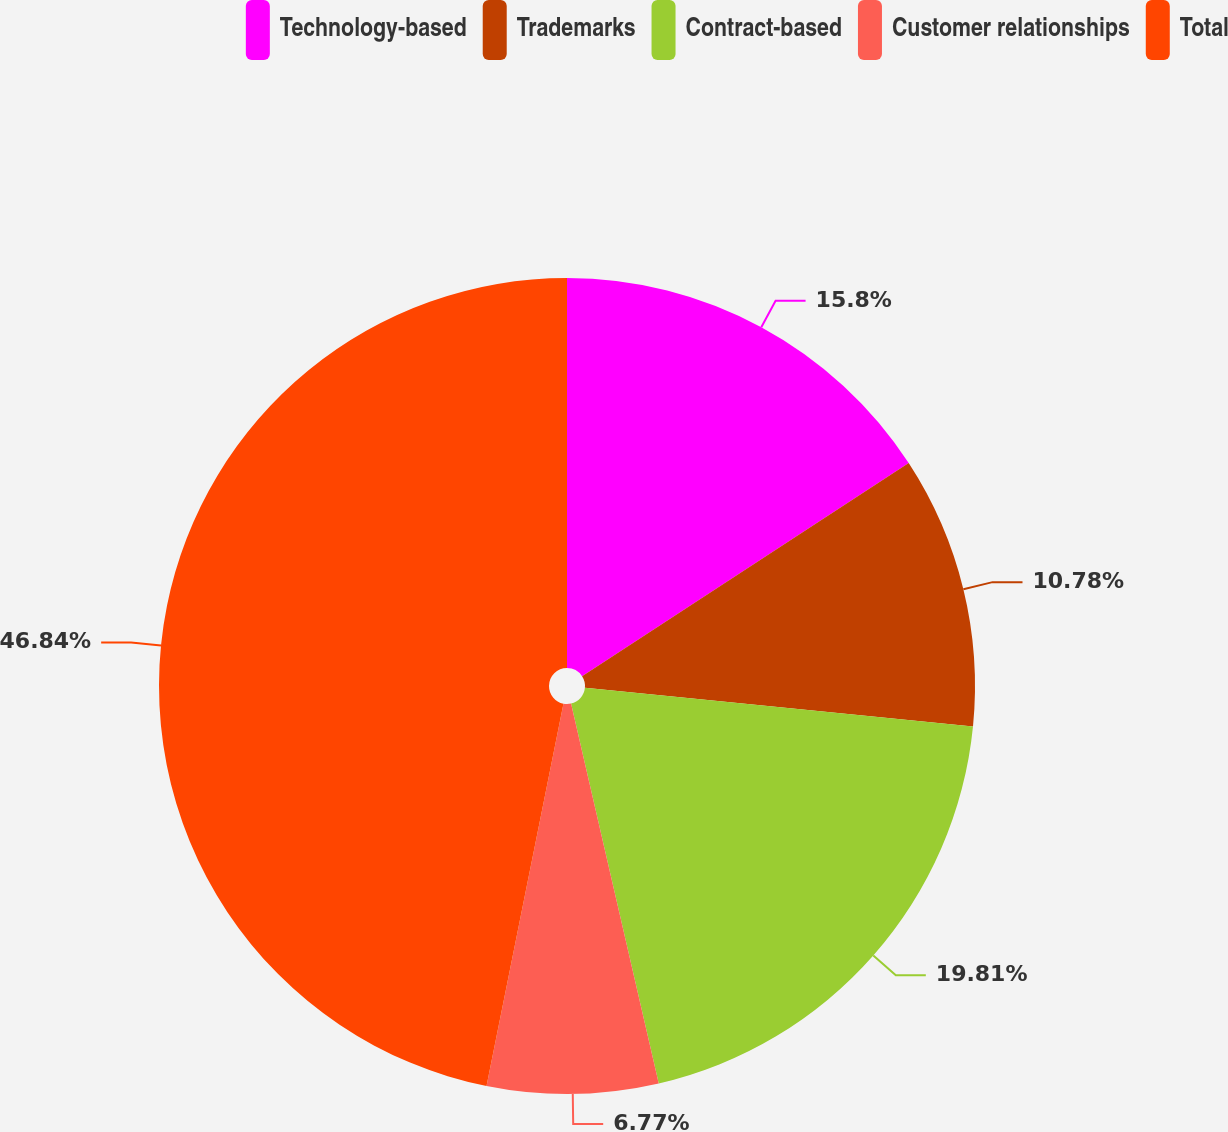<chart> <loc_0><loc_0><loc_500><loc_500><pie_chart><fcel>Technology-based<fcel>Trademarks<fcel>Contract-based<fcel>Customer relationships<fcel>Total<nl><fcel>15.8%<fcel>10.78%<fcel>19.81%<fcel>6.77%<fcel>46.84%<nl></chart> 